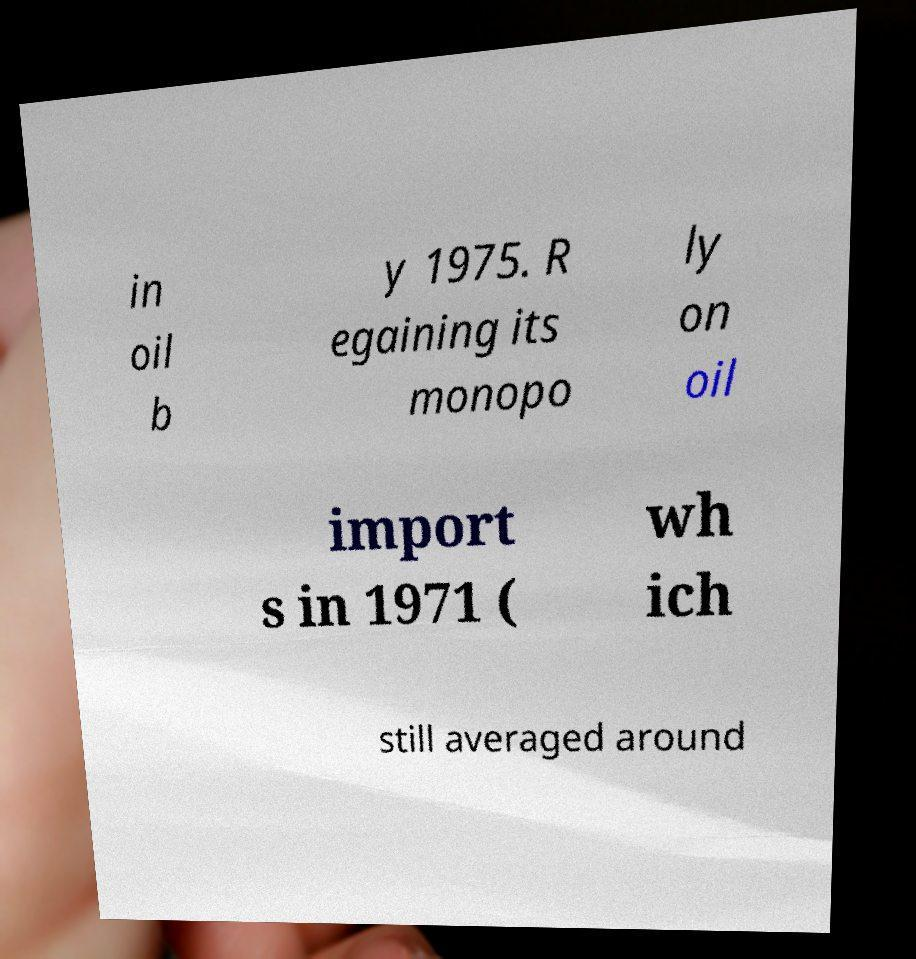For documentation purposes, I need the text within this image transcribed. Could you provide that? in oil b y 1975. R egaining its monopo ly on oil import s in 1971 ( wh ich still averaged around 